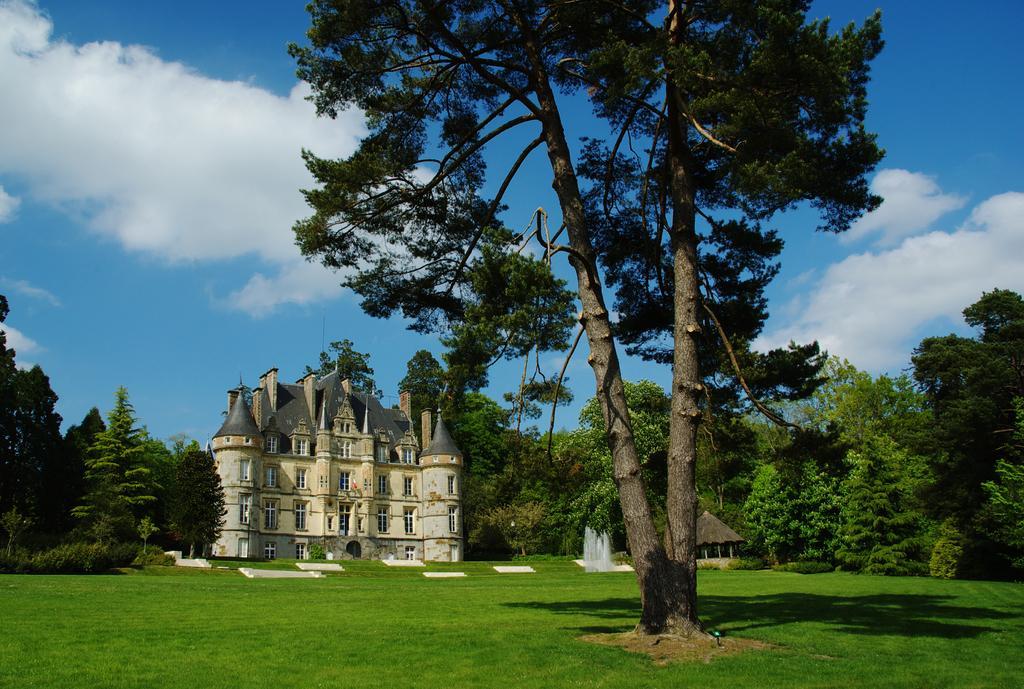How would you summarize this image in a sentence or two? In this picture we can see few trees, in the background we can find a building and water. 